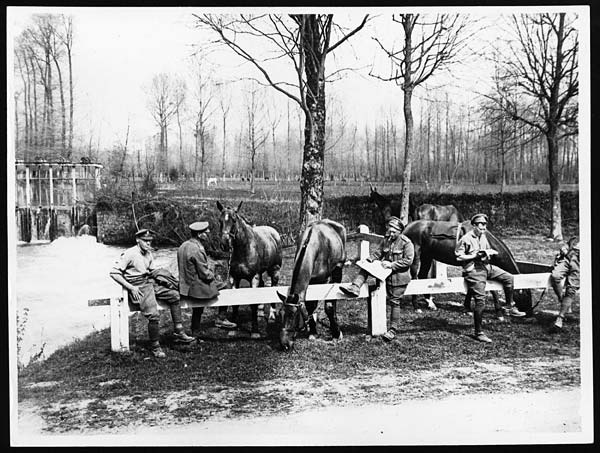Describe the objects in this image and their specific colors. I can see horse in black, gray, lightgray, and darkgray tones, horse in black, gray, darkgray, and lightgray tones, people in black, lightgray, gray, and darkgray tones, horse in black, gray, darkgray, and lightgray tones, and people in black, lightgray, gray, and darkgray tones in this image. 